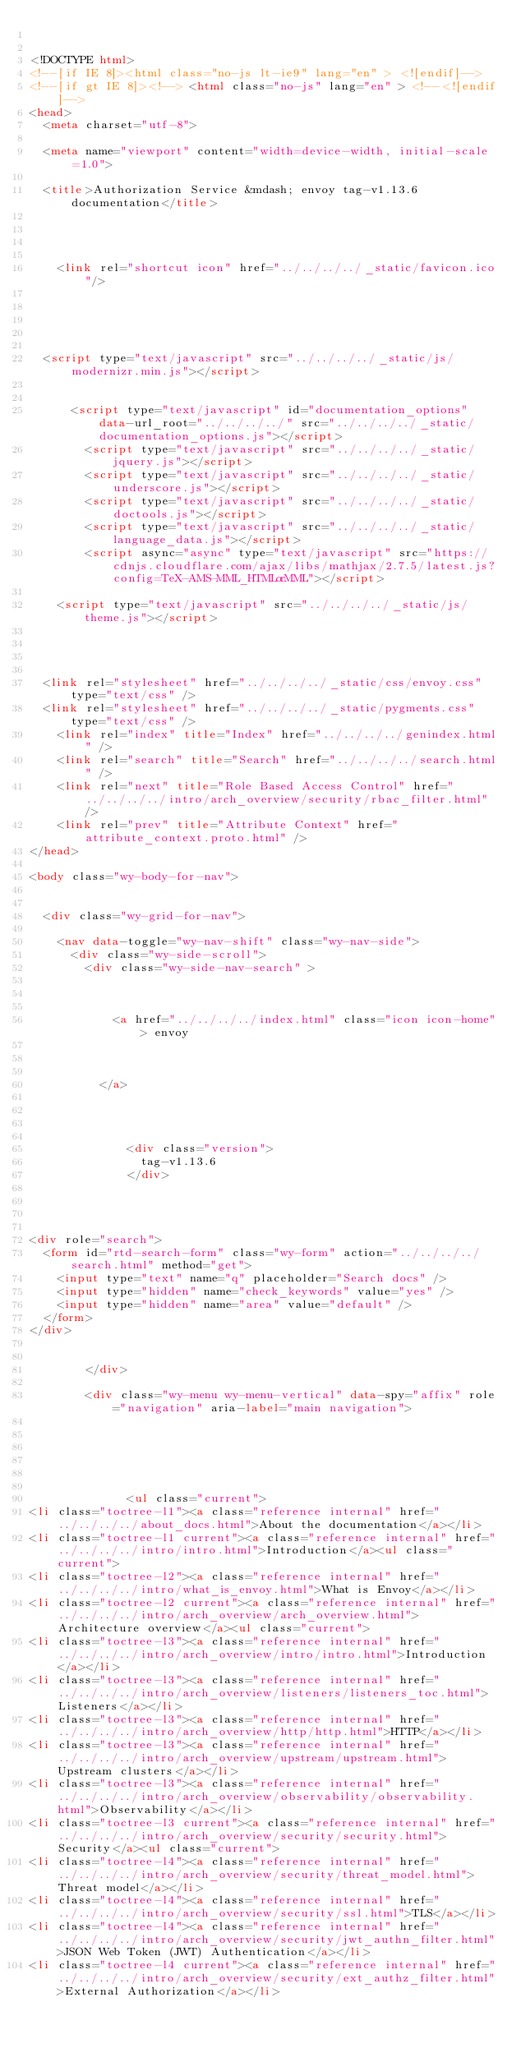Convert code to text. <code><loc_0><loc_0><loc_500><loc_500><_HTML_>

<!DOCTYPE html>
<!--[if IE 8]><html class="no-js lt-ie9" lang="en" > <![endif]-->
<!--[if gt IE 8]><!--> <html class="no-js" lang="en" > <!--<![endif]-->
<head>
  <meta charset="utf-8">
  
  <meta name="viewport" content="width=device-width, initial-scale=1.0">
  
  <title>Authorization Service &mdash; envoy tag-v1.13.6 documentation</title>
  

  
  
    <link rel="shortcut icon" href="../../../../_static/favicon.ico"/>
  
  
  

  
  <script type="text/javascript" src="../../../../_static/js/modernizr.min.js"></script>
  
    
      <script type="text/javascript" id="documentation_options" data-url_root="../../../../" src="../../../../_static/documentation_options.js"></script>
        <script type="text/javascript" src="../../../../_static/jquery.js"></script>
        <script type="text/javascript" src="../../../../_static/underscore.js"></script>
        <script type="text/javascript" src="../../../../_static/doctools.js"></script>
        <script type="text/javascript" src="../../../../_static/language_data.js"></script>
        <script async="async" type="text/javascript" src="https://cdnjs.cloudflare.com/ajax/libs/mathjax/2.7.5/latest.js?config=TeX-AMS-MML_HTMLorMML"></script>
    
    <script type="text/javascript" src="../../../../_static/js/theme.js"></script>

    

  
  <link rel="stylesheet" href="../../../../_static/css/envoy.css" type="text/css" />
  <link rel="stylesheet" href="../../../../_static/pygments.css" type="text/css" />
    <link rel="index" title="Index" href="../../../../genindex.html" />
    <link rel="search" title="Search" href="../../../../search.html" />
    <link rel="next" title="Role Based Access Control" href="../../../../intro/arch_overview/security/rbac_filter.html" />
    <link rel="prev" title="Attribute Context" href="attribute_context.proto.html" /> 
</head>

<body class="wy-body-for-nav">

   
  <div class="wy-grid-for-nav">
    
    <nav data-toggle="wy-nav-shift" class="wy-nav-side">
      <div class="wy-side-scroll">
        <div class="wy-side-nav-search" >
          

          
            <a href="../../../../index.html" class="icon icon-home"> envoy
          

          
          </a>

          
            
            
              <div class="version">
                tag-v1.13.6
              </div>
            
          

          
<div role="search">
  <form id="rtd-search-form" class="wy-form" action="../../../../search.html" method="get">
    <input type="text" name="q" placeholder="Search docs" />
    <input type="hidden" name="check_keywords" value="yes" />
    <input type="hidden" name="area" value="default" />
  </form>
</div>

          
        </div>

        <div class="wy-menu wy-menu-vertical" data-spy="affix" role="navigation" aria-label="main navigation">
          
            
            
              
            
            
              <ul class="current">
<li class="toctree-l1"><a class="reference internal" href="../../../../about_docs.html">About the documentation</a></li>
<li class="toctree-l1 current"><a class="reference internal" href="../../../../intro/intro.html">Introduction</a><ul class="current">
<li class="toctree-l2"><a class="reference internal" href="../../../../intro/what_is_envoy.html">What is Envoy</a></li>
<li class="toctree-l2 current"><a class="reference internal" href="../../../../intro/arch_overview/arch_overview.html">Architecture overview</a><ul class="current">
<li class="toctree-l3"><a class="reference internal" href="../../../../intro/arch_overview/intro/intro.html">Introduction</a></li>
<li class="toctree-l3"><a class="reference internal" href="../../../../intro/arch_overview/listeners/listeners_toc.html">Listeners</a></li>
<li class="toctree-l3"><a class="reference internal" href="../../../../intro/arch_overview/http/http.html">HTTP</a></li>
<li class="toctree-l3"><a class="reference internal" href="../../../../intro/arch_overview/upstream/upstream.html">Upstream clusters</a></li>
<li class="toctree-l3"><a class="reference internal" href="../../../../intro/arch_overview/observability/observability.html">Observability</a></li>
<li class="toctree-l3 current"><a class="reference internal" href="../../../../intro/arch_overview/security/security.html">Security</a><ul class="current">
<li class="toctree-l4"><a class="reference internal" href="../../../../intro/arch_overview/security/threat_model.html">Threat model</a></li>
<li class="toctree-l4"><a class="reference internal" href="../../../../intro/arch_overview/security/ssl.html">TLS</a></li>
<li class="toctree-l4"><a class="reference internal" href="../../../../intro/arch_overview/security/jwt_authn_filter.html">JSON Web Token (JWT) Authentication</a></li>
<li class="toctree-l4 current"><a class="reference internal" href="../../../../intro/arch_overview/security/ext_authz_filter.html">External Authorization</a></li></code> 